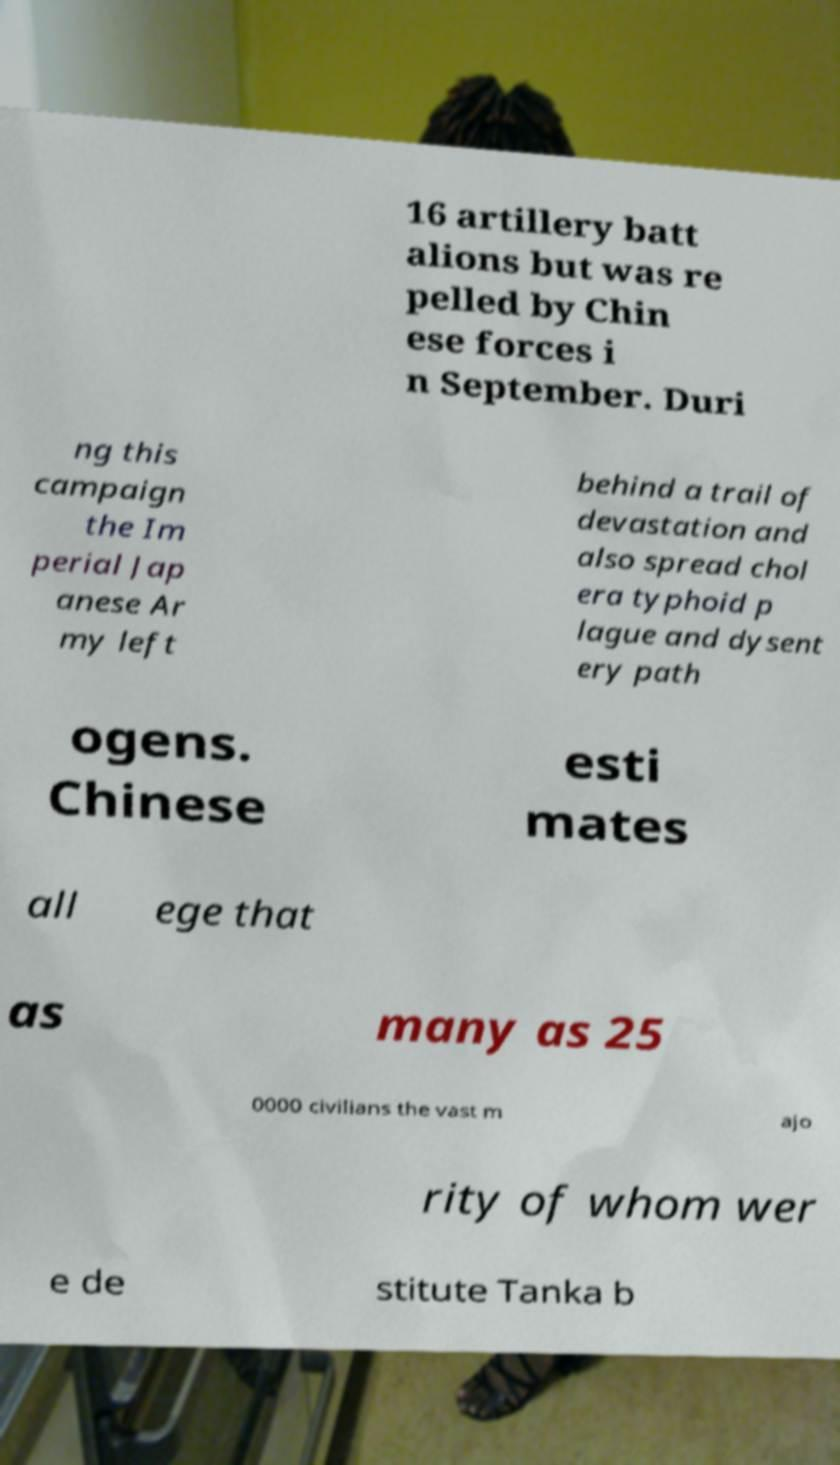Can you read and provide the text displayed in the image?This photo seems to have some interesting text. Can you extract and type it out for me? 16 artillery batt alions but was re pelled by Chin ese forces i n September. Duri ng this campaign the Im perial Jap anese Ar my left behind a trail of devastation and also spread chol era typhoid p lague and dysent ery path ogens. Chinese esti mates all ege that as many as 25 0000 civilians the vast m ajo rity of whom wer e de stitute Tanka b 